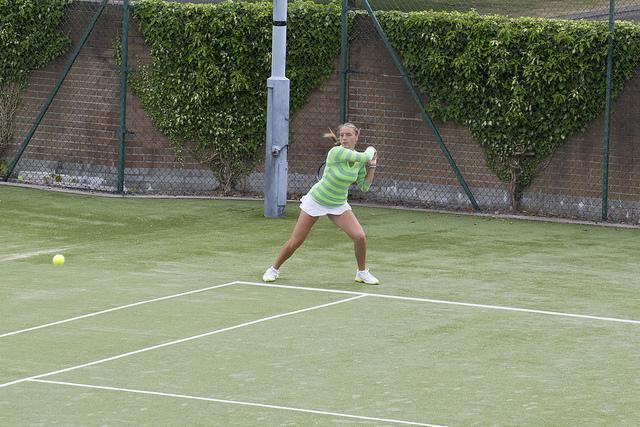How many characters on the digitized reader board on the top front of the bus are numerals?
Give a very brief answer. 0. 